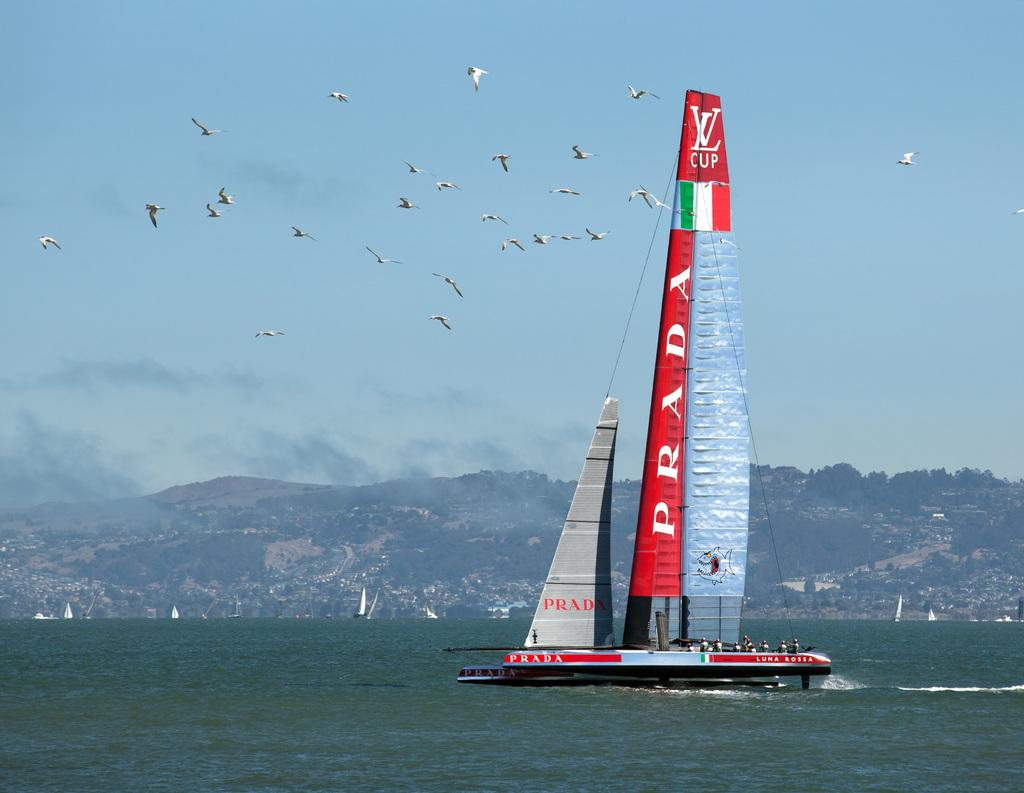<image>
Share a concise interpretation of the image provided. White and red ship that says  Prada on the sail. 